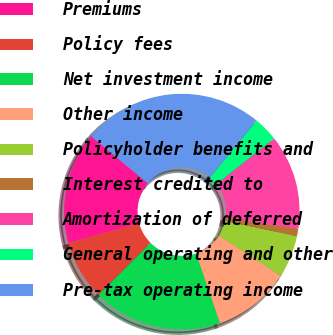Convert chart to OTSL. <chart><loc_0><loc_0><loc_500><loc_500><pie_chart><fcel>Premiums<fcel>Policy fees<fcel>Net investment income<fcel>Other income<fcel>Policyholder benefits and<fcel>Interest credited to<fcel>Amortization of deferred<fcel>General operating and other<fcel>Pre-tax operating income<nl><fcel>15.35%<fcel>8.2%<fcel>17.74%<fcel>10.58%<fcel>5.81%<fcel>1.04%<fcel>12.97%<fcel>3.42%<fcel>24.9%<nl></chart> 